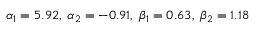Convert formula to latex. <formula><loc_0><loc_0><loc_500><loc_500>\alpha _ { 1 } = 5 . 9 2 , \, \alpha _ { 2 } = - 0 . 9 1 , \, \beta _ { 1 } = 0 . 6 3 , \, \beta _ { 2 } = 1 . 1 8</formula> 